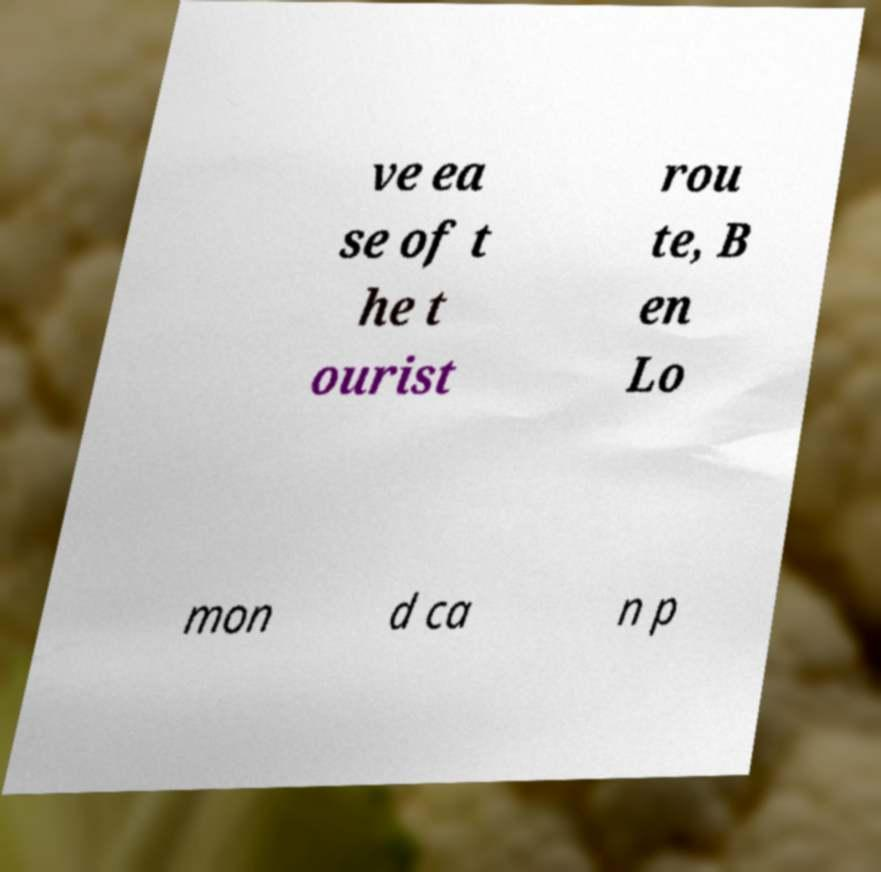I need the written content from this picture converted into text. Can you do that? ve ea se of t he t ourist rou te, B en Lo mon d ca n p 